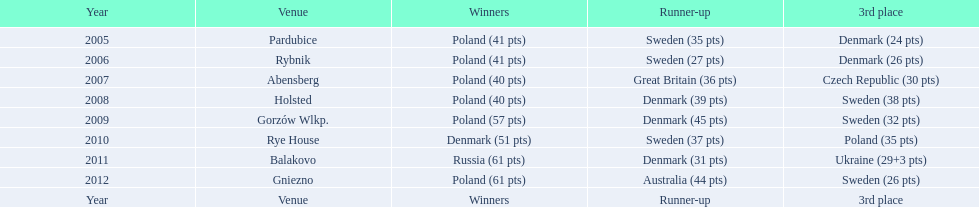From 2005 to 2012, which team accumulated the greatest number of third-place wins in the speedway junior world championship? Sweden. 